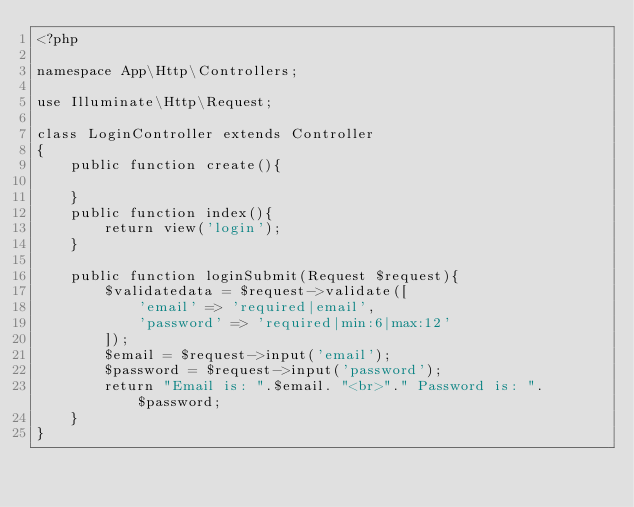<code> <loc_0><loc_0><loc_500><loc_500><_PHP_><?php

namespace App\Http\Controllers;

use Illuminate\Http\Request;

class LoginController extends Controller
{
    public function create(){
        
    }
    public function index(){
        return view('login');
    }

    public function loginSubmit(Request $request){
        $validatedata = $request->validate([
            'email' => 'required|email',
            'password' => 'required|min:6|max:12'                                                                
        ]);
        $email = $request->input('email');
        $password = $request->input('password');
        return "Email is: ".$email. "<br>"." Password is: ".$password;
    }
}
</code> 